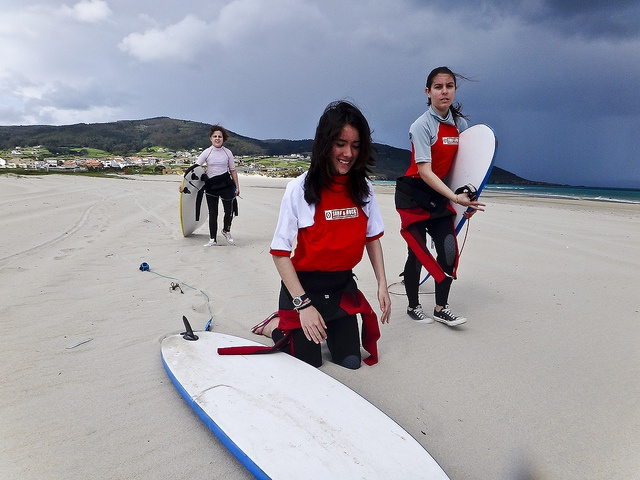Describe the objects in this image and their specific colors. I can see surfboard in lavender, darkgray, blue, and gray tones, people in lavender, black, and maroon tones, people in lavender, black, maroon, and darkgray tones, people in lavender, black, darkgray, lightgray, and gray tones, and surfboard in lavender, lightgray, darkgray, black, and navy tones in this image. 